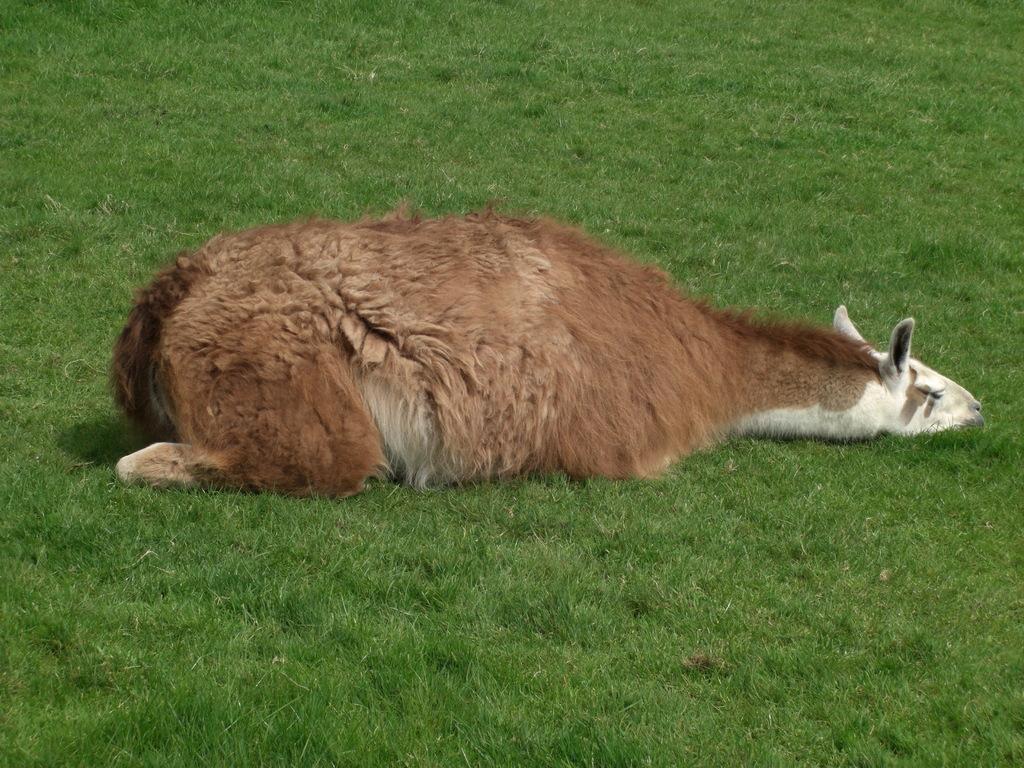In one or two sentences, can you explain what this image depicts? In this image we can see an animal on the ground and also we can see the grass. 